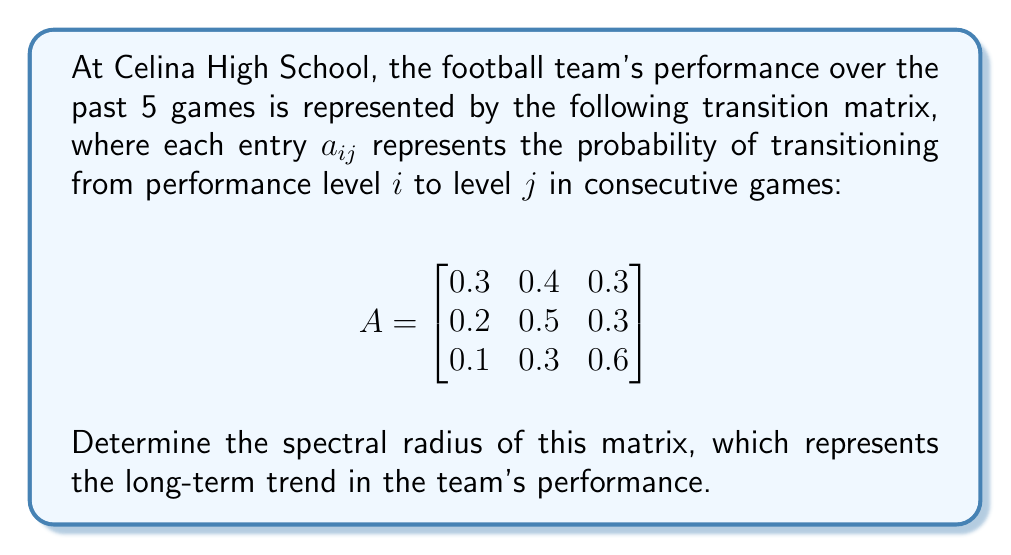Can you solve this math problem? To find the spectral radius of matrix A, we need to follow these steps:

1) First, calculate the characteristic polynomial of A:
   $det(A - \lambda I) = 0$

   $$\begin{vmatrix}
   0.3 - \lambda & 0.4 & 0.3 \\
   0.2 & 0.5 - \lambda & 0.3 \\
   0.1 & 0.3 & 0.6 - \lambda
   \end{vmatrix} = 0$$

2) Expanding the determinant:
   $(\lambda - 0.3)(\lambda - 0.5)(\lambda - 0.6) - 0.4 \cdot 0.2 \cdot 0.3 - 0.3 \cdot 0.3 \cdot 0.1 - 0.3 \cdot 0.2 \cdot 0.3 = 0$

3) Simplify:
   $\lambda^3 - 1.4\lambda^2 + 0.59\lambda - 0.024 = 0$

4) The eigenvalues are the roots of this polynomial. We can use a numerical method to find them:
   $\lambda_1 \approx 1$
   $\lambda_2 \approx 0.2$
   $\lambda_3 \approx 0.2$

5) The spectral radius is the largest absolute value among the eigenvalues:
   $\rho(A) = \max(|\lambda_1|, |\lambda_2|, |\lambda_3|) = \max(1, 0.2, 0.2) = 1$

Therefore, the spectral radius of the matrix is 1.
Answer: 1 